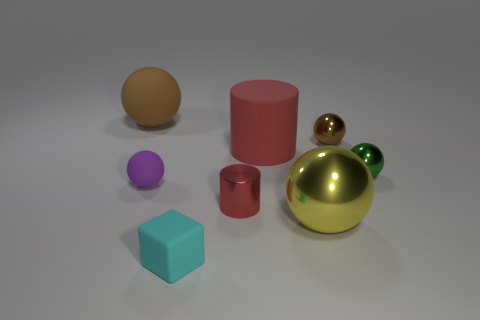Subtract all green blocks. How many brown balls are left? 2 Subtract all yellow metallic balls. How many balls are left? 4 Subtract all green spheres. How many spheres are left? 4 Subtract 1 spheres. How many spheres are left? 4 Add 1 big purple shiny spheres. How many objects exist? 9 Subtract all cylinders. How many objects are left? 6 Subtract all cyan balls. Subtract all green cubes. How many balls are left? 5 Subtract all tiny rubber cubes. Subtract all small things. How many objects are left? 2 Add 7 yellow metal objects. How many yellow metal objects are left? 8 Add 5 big red rubber things. How many big red rubber things exist? 6 